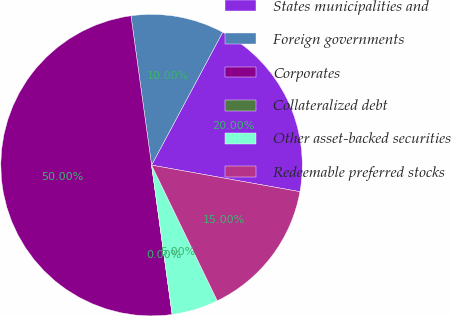Convert chart to OTSL. <chart><loc_0><loc_0><loc_500><loc_500><pie_chart><fcel>States municipalities and<fcel>Foreign governments<fcel>Corporates<fcel>Collateralized debt<fcel>Other asset-backed securities<fcel>Redeemable preferred stocks<nl><fcel>20.0%<fcel>10.0%<fcel>50.0%<fcel>0.0%<fcel>5.0%<fcel>15.0%<nl></chart> 